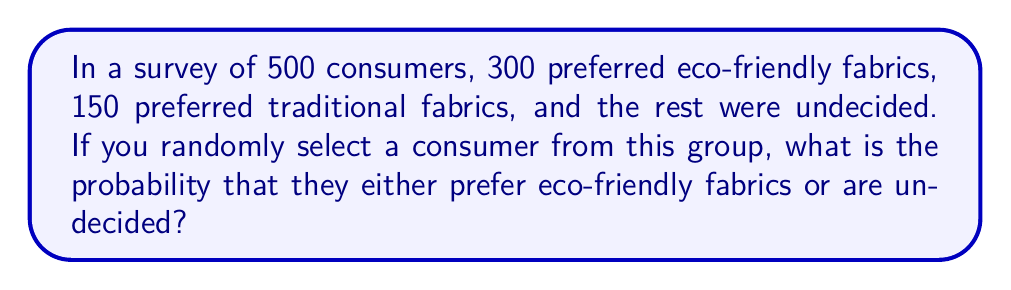Show me your answer to this math problem. Let's approach this step-by-step:

1) First, we need to determine the number of undecided consumers:
   Total consumers = 500
   Eco-friendly preference = 300
   Traditional preference = 150
   Undecided = 500 - 300 - 150 = 50

2) Now, we need to calculate the probability of selecting a consumer who either prefers eco-friendly fabrics or is undecided:

   $$P(\text{Eco-friendly or Undecided}) = \frac{\text{Number of favorable outcomes}}{\text{Total number of possible outcomes}}$$

3) The favorable outcomes are:
   Eco-friendly preference + Undecided = 300 + 50 = 350

4) The total number of possible outcomes is the total number of consumers: 500

5) Therefore, the probability is:

   $$P(\text{Eco-friendly or Undecided}) = \frac{350}{500} = \frac{7}{10} = 0.7$$

This result indicates that there's a 70% chance of randomly selecting a consumer who either prefers eco-friendly fabrics or is undecided, which is a strong indicator of potential market interest in sustainable textiles.
Answer: $\frac{7}{10}$ or 0.7 